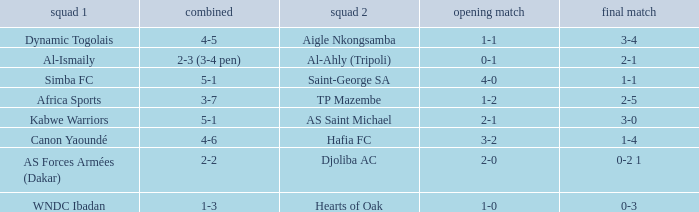What team played against Hafia FC (team 2)? Canon Yaoundé. 